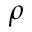Convert formula to latex. <formula><loc_0><loc_0><loc_500><loc_500>\rho</formula> 